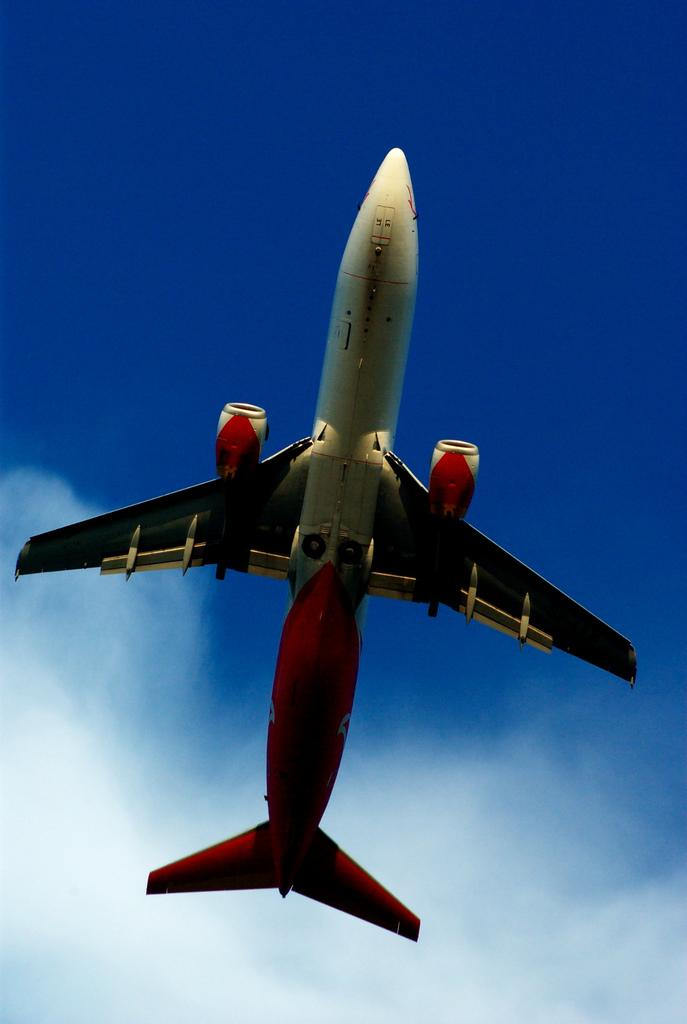What is the main subject of the picture? The main subject of the picture is an airplane. What colors are used for the airplane? The airplane is in white and red colors. What is the airplane doing in the image? The airplane is flying in the sky. What can be seen in the background of the image? The sky is visible in the background of the image. What is the color of the sky in the image? The sky is blue in color. How many worms can be seen crawling on the floor in the image? There are no worms or floors present in the image; it features an airplane flying in the sky. What type of cows are grazing on the grass in the image? There are no cows or grass present in the image; it features an airplane flying in the sky. 